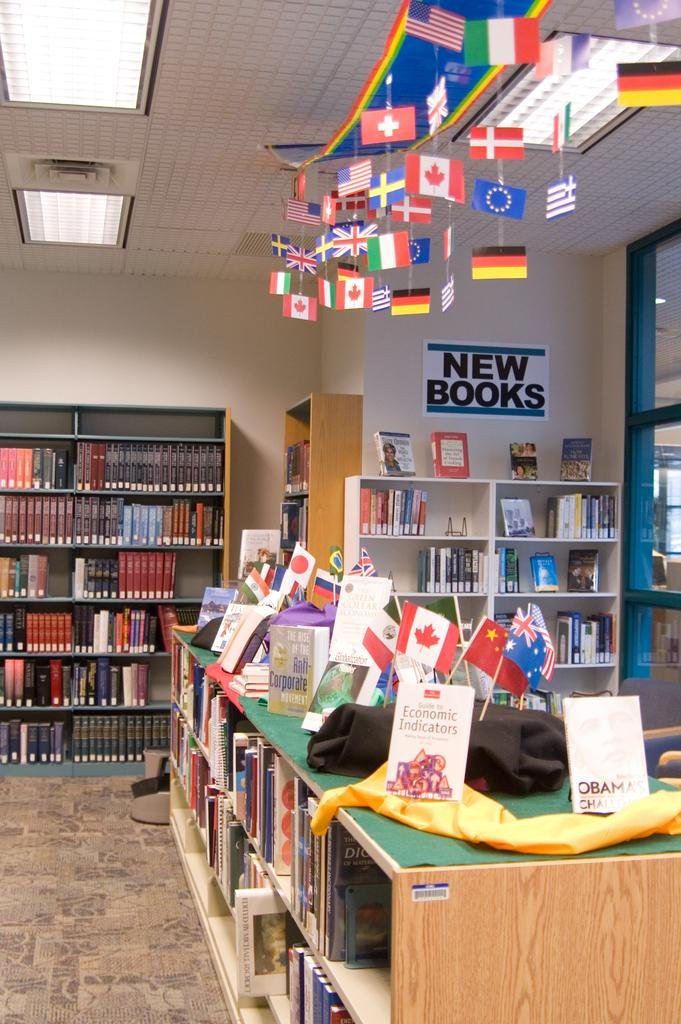<image>
Render a clear and concise summary of the photo. A sign that says "new books" hangs on a library wall. 